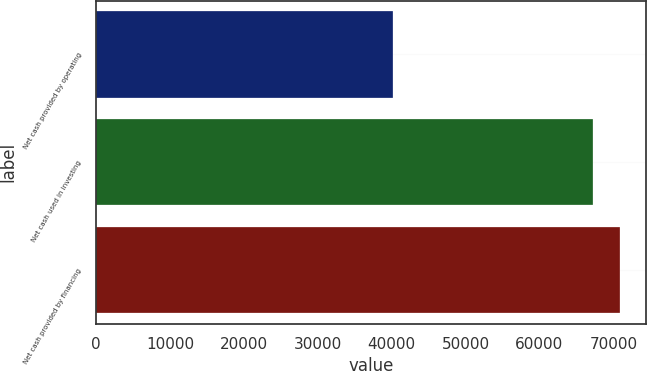Convert chart to OTSL. <chart><loc_0><loc_0><loc_500><loc_500><bar_chart><fcel>Net cash provided by operating<fcel>Net cash used in investing<fcel>Net cash provided by financing<nl><fcel>40114<fcel>67301<fcel>70870<nl></chart> 